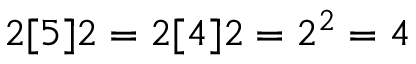Convert formula to latex. <formula><loc_0><loc_0><loc_500><loc_500>2 [ 5 ] 2 = 2 [ 4 ] 2 = 2 ^ { 2 } = 4</formula> 